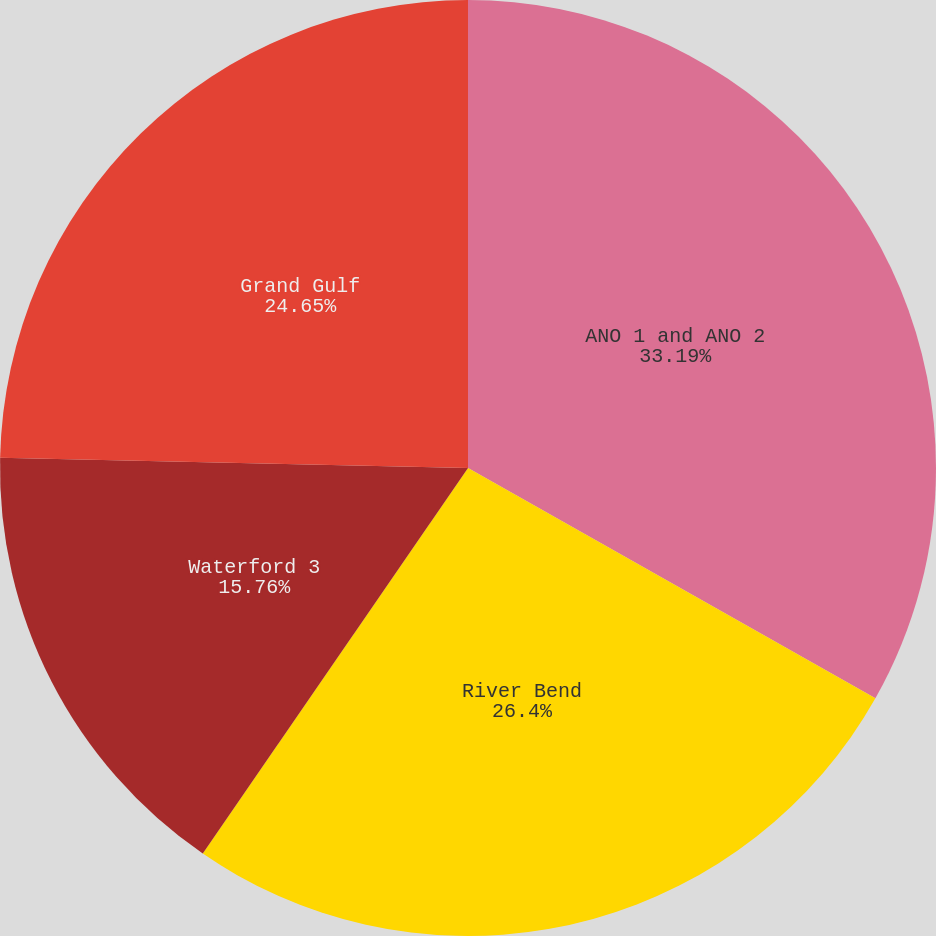<chart> <loc_0><loc_0><loc_500><loc_500><pie_chart><fcel>ANO 1 and ANO 2<fcel>River Bend<fcel>Waterford 3<fcel>Grand Gulf<nl><fcel>33.19%<fcel>26.4%<fcel>15.76%<fcel>24.65%<nl></chart> 